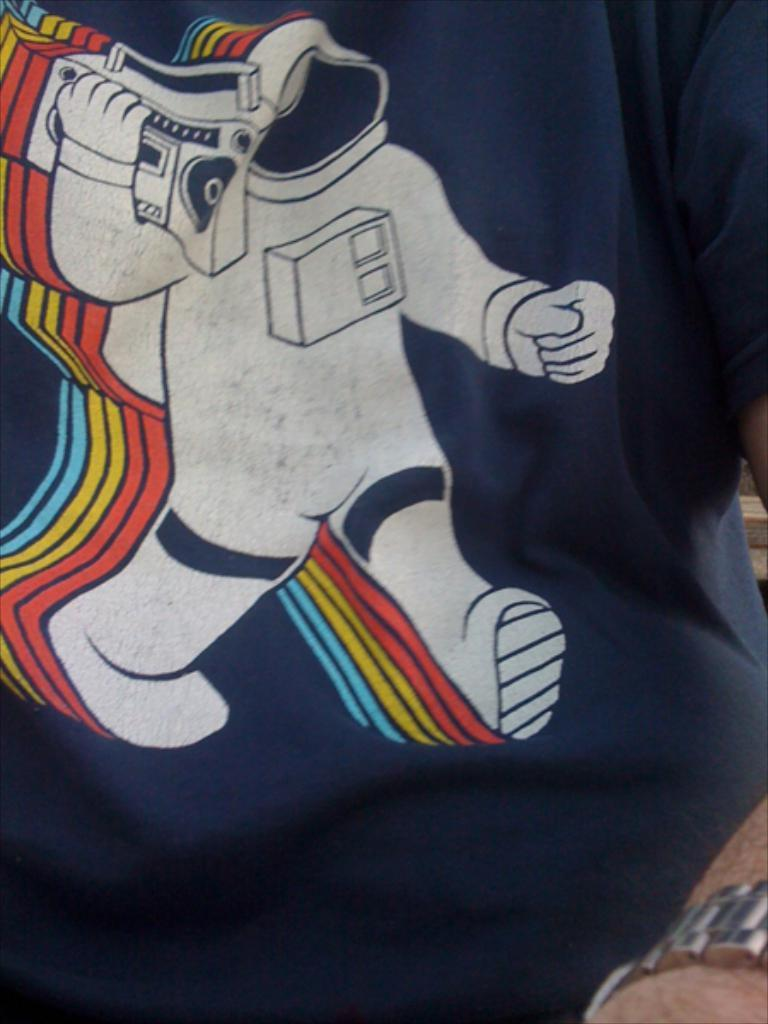What part of a person's body is visible in the image? There is a person's hand in the image. What is the person wearing in the image? The person is wearing a blue dress. Can you describe the unspecified object in the image? Unfortunately, the facts provided do not give enough information to describe the unspecified object in the image. What time of day is it in the image, considering the afternoon? The facts provided do not give any information about the time of day, so it cannot be determined if it is afternoon or not. 